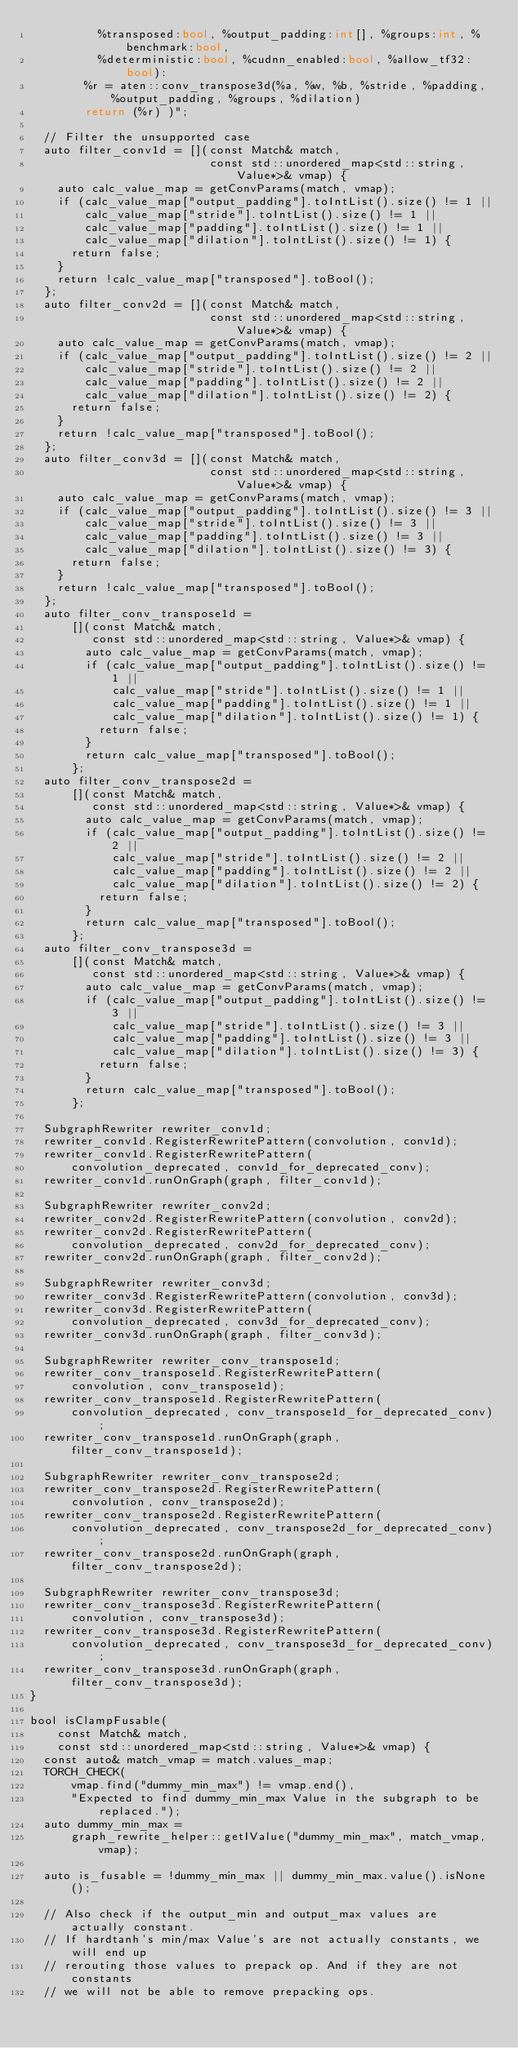Convert code to text. <code><loc_0><loc_0><loc_500><loc_500><_C++_>          %transposed:bool, %output_padding:int[], %groups:int, %benchmark:bool,
          %deterministic:bool, %cudnn_enabled:bool, %allow_tf32:bool):
        %r = aten::conv_transpose3d(%a, %w, %b, %stride, %padding, %output_padding, %groups, %dilation)
        return (%r) )";

  // Filter the unsupported case
  auto filter_conv1d = [](const Match& match,
                          const std::unordered_map<std::string, Value*>& vmap) {
    auto calc_value_map = getConvParams(match, vmap);
    if (calc_value_map["output_padding"].toIntList().size() != 1 ||
        calc_value_map["stride"].toIntList().size() != 1 ||
        calc_value_map["padding"].toIntList().size() != 1 ||
        calc_value_map["dilation"].toIntList().size() != 1) {
      return false;
    }
    return !calc_value_map["transposed"].toBool();
  };
  auto filter_conv2d = [](const Match& match,
                          const std::unordered_map<std::string, Value*>& vmap) {
    auto calc_value_map = getConvParams(match, vmap);
    if (calc_value_map["output_padding"].toIntList().size() != 2 ||
        calc_value_map["stride"].toIntList().size() != 2 ||
        calc_value_map["padding"].toIntList().size() != 2 ||
        calc_value_map["dilation"].toIntList().size() != 2) {
      return false;
    }
    return !calc_value_map["transposed"].toBool();
  };
  auto filter_conv3d = [](const Match& match,
                          const std::unordered_map<std::string, Value*>& vmap) {
    auto calc_value_map = getConvParams(match, vmap);
    if (calc_value_map["output_padding"].toIntList().size() != 3 ||
        calc_value_map["stride"].toIntList().size() != 3 ||
        calc_value_map["padding"].toIntList().size() != 3 ||
        calc_value_map["dilation"].toIntList().size() != 3) {
      return false;
    }
    return !calc_value_map["transposed"].toBool();
  };
  auto filter_conv_transpose1d =
      [](const Match& match,
         const std::unordered_map<std::string, Value*>& vmap) {
        auto calc_value_map = getConvParams(match, vmap);
        if (calc_value_map["output_padding"].toIntList().size() != 1 ||
            calc_value_map["stride"].toIntList().size() != 1 ||
            calc_value_map["padding"].toIntList().size() != 1 ||
            calc_value_map["dilation"].toIntList().size() != 1) {
          return false;
        }
        return calc_value_map["transposed"].toBool();
      };
  auto filter_conv_transpose2d =
      [](const Match& match,
         const std::unordered_map<std::string, Value*>& vmap) {
        auto calc_value_map = getConvParams(match, vmap);
        if (calc_value_map["output_padding"].toIntList().size() != 2 ||
            calc_value_map["stride"].toIntList().size() != 2 ||
            calc_value_map["padding"].toIntList().size() != 2 ||
            calc_value_map["dilation"].toIntList().size() != 2) {
          return false;
        }
        return calc_value_map["transposed"].toBool();
      };
  auto filter_conv_transpose3d =
      [](const Match& match,
         const std::unordered_map<std::string, Value*>& vmap) {
        auto calc_value_map = getConvParams(match, vmap);
        if (calc_value_map["output_padding"].toIntList().size() != 3 ||
            calc_value_map["stride"].toIntList().size() != 3 ||
            calc_value_map["padding"].toIntList().size() != 3 ||
            calc_value_map["dilation"].toIntList().size() != 3) {
          return false;
        }
        return calc_value_map["transposed"].toBool();
      };

  SubgraphRewriter rewriter_conv1d;
  rewriter_conv1d.RegisterRewritePattern(convolution, conv1d);
  rewriter_conv1d.RegisterRewritePattern(
      convolution_deprecated, conv1d_for_deprecated_conv);
  rewriter_conv1d.runOnGraph(graph, filter_conv1d);

  SubgraphRewriter rewriter_conv2d;
  rewriter_conv2d.RegisterRewritePattern(convolution, conv2d);
  rewriter_conv2d.RegisterRewritePattern(
      convolution_deprecated, conv2d_for_deprecated_conv);
  rewriter_conv2d.runOnGraph(graph, filter_conv2d);

  SubgraphRewriter rewriter_conv3d;
  rewriter_conv3d.RegisterRewritePattern(convolution, conv3d);
  rewriter_conv3d.RegisterRewritePattern(
      convolution_deprecated, conv3d_for_deprecated_conv);
  rewriter_conv3d.runOnGraph(graph, filter_conv3d);

  SubgraphRewriter rewriter_conv_transpose1d;
  rewriter_conv_transpose1d.RegisterRewritePattern(
      convolution, conv_transpose1d);
  rewriter_conv_transpose1d.RegisterRewritePattern(
      convolution_deprecated, conv_transpose1d_for_deprecated_conv);
  rewriter_conv_transpose1d.runOnGraph(graph, filter_conv_transpose1d);

  SubgraphRewriter rewriter_conv_transpose2d;
  rewriter_conv_transpose2d.RegisterRewritePattern(
      convolution, conv_transpose2d);
  rewriter_conv_transpose2d.RegisterRewritePattern(
      convolution_deprecated, conv_transpose2d_for_deprecated_conv);
  rewriter_conv_transpose2d.runOnGraph(graph, filter_conv_transpose2d);

  SubgraphRewriter rewriter_conv_transpose3d;
  rewriter_conv_transpose3d.RegisterRewritePattern(
      convolution, conv_transpose3d);
  rewriter_conv_transpose3d.RegisterRewritePattern(
      convolution_deprecated, conv_transpose3d_for_deprecated_conv);
  rewriter_conv_transpose3d.runOnGraph(graph, filter_conv_transpose3d);
}

bool isClampFusable(
    const Match& match,
    const std::unordered_map<std::string, Value*>& vmap) {
  const auto& match_vmap = match.values_map;
  TORCH_CHECK(
      vmap.find("dummy_min_max") != vmap.end(),
      "Expected to find dummy_min_max Value in the subgraph to be replaced.");
  auto dummy_min_max =
      graph_rewrite_helper::getIValue("dummy_min_max", match_vmap, vmap);

  auto is_fusable = !dummy_min_max || dummy_min_max.value().isNone();

  // Also check if the output_min and output_max values are actually constant.
  // If hardtanh's min/max Value's are not actually constants, we will end up
  // rerouting those values to prepack op. And if they are not constants
  // we will not be able to remove prepacking ops.</code> 